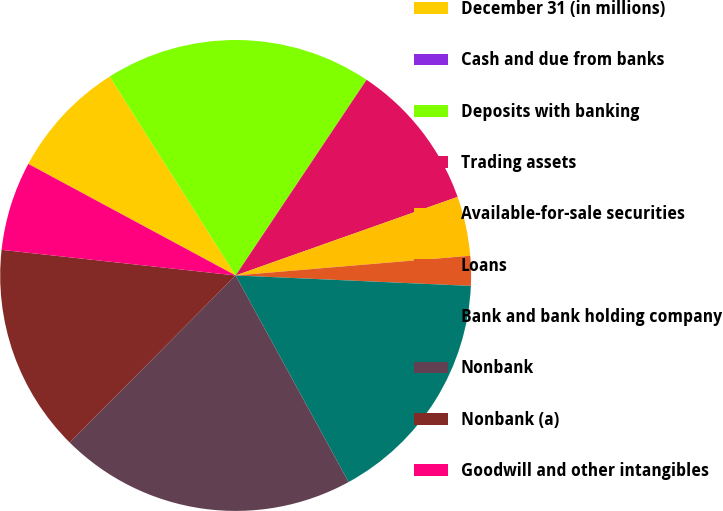Convert chart to OTSL. <chart><loc_0><loc_0><loc_500><loc_500><pie_chart><fcel>December 31 (in millions)<fcel>Cash and due from banks<fcel>Deposits with banking<fcel>Trading assets<fcel>Available-for-sale securities<fcel>Loans<fcel>Bank and bank holding company<fcel>Nonbank<fcel>Nonbank (a)<fcel>Goodwill and other intangibles<nl><fcel>8.16%<fcel>0.0%<fcel>18.37%<fcel>10.2%<fcel>4.08%<fcel>2.04%<fcel>16.33%<fcel>20.41%<fcel>14.29%<fcel>6.12%<nl></chart> 